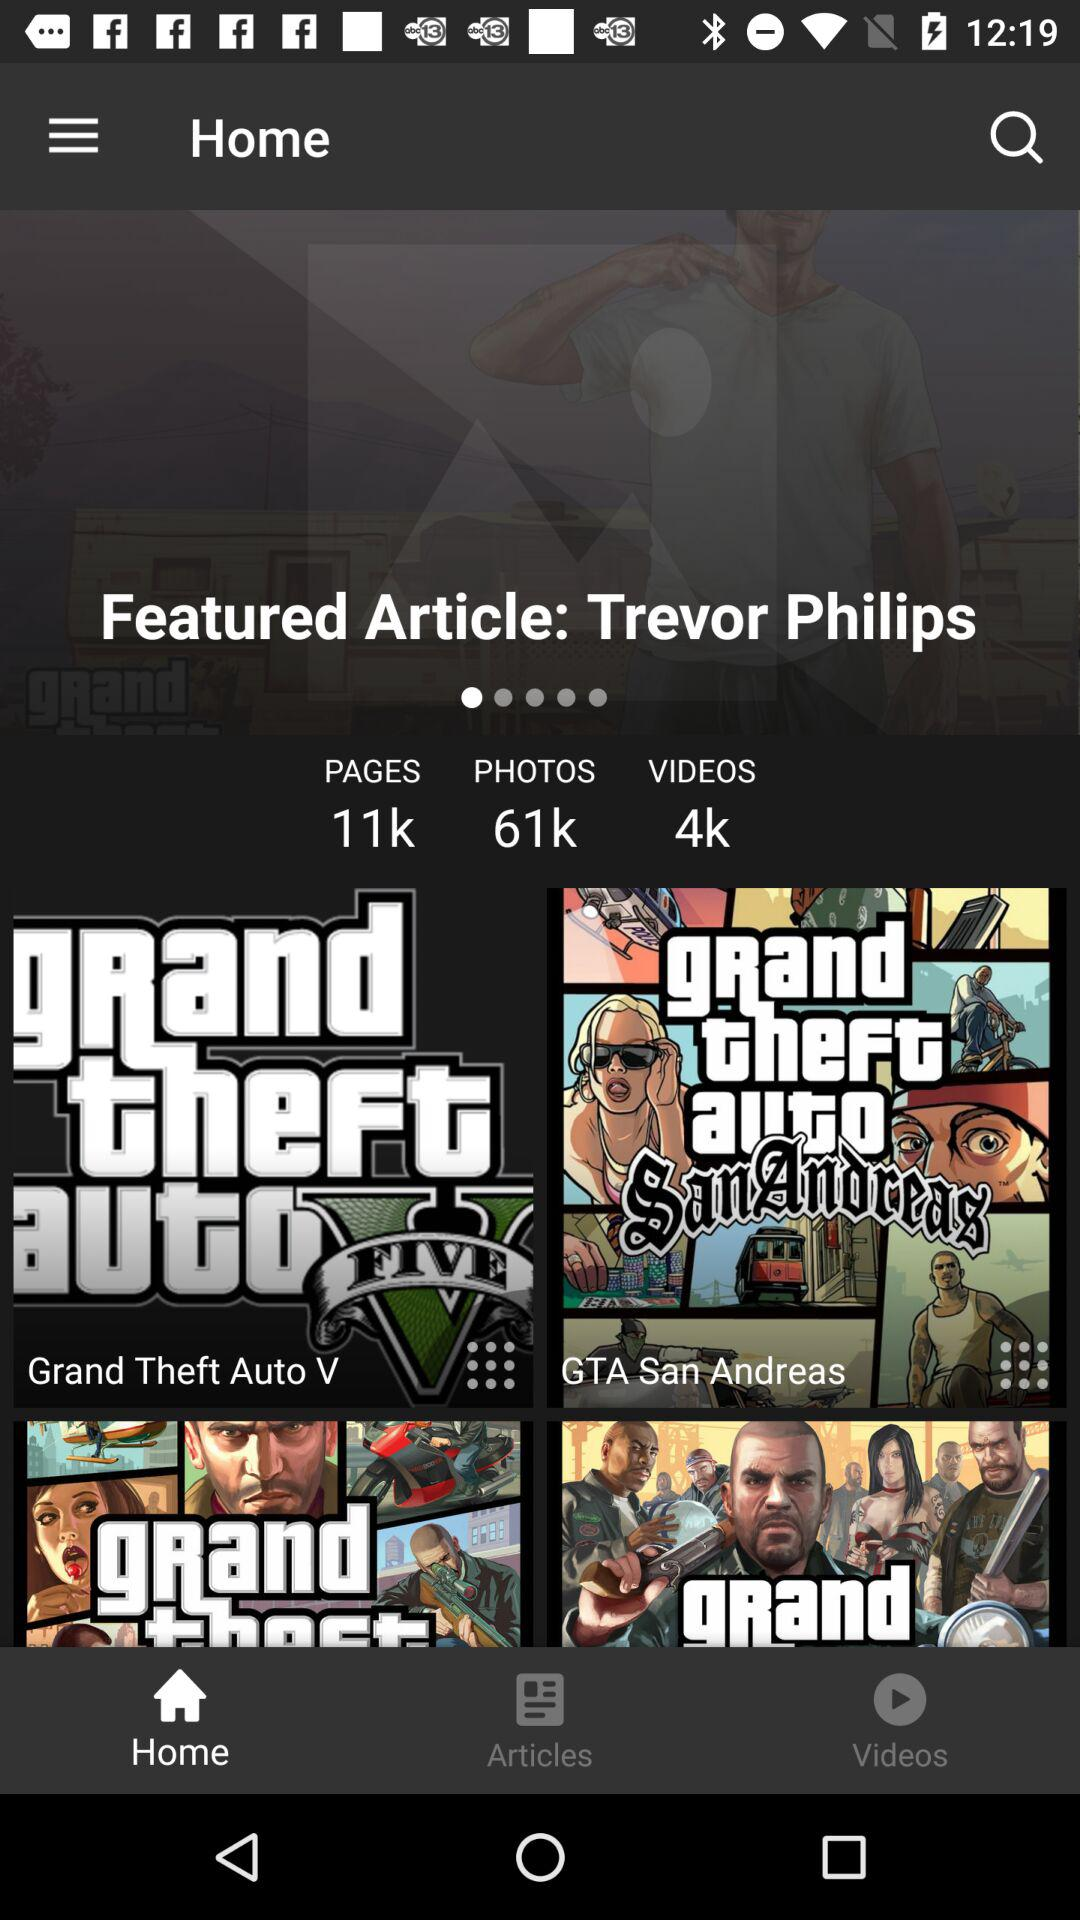How many pages in total are there? There are 11k pages in total. 